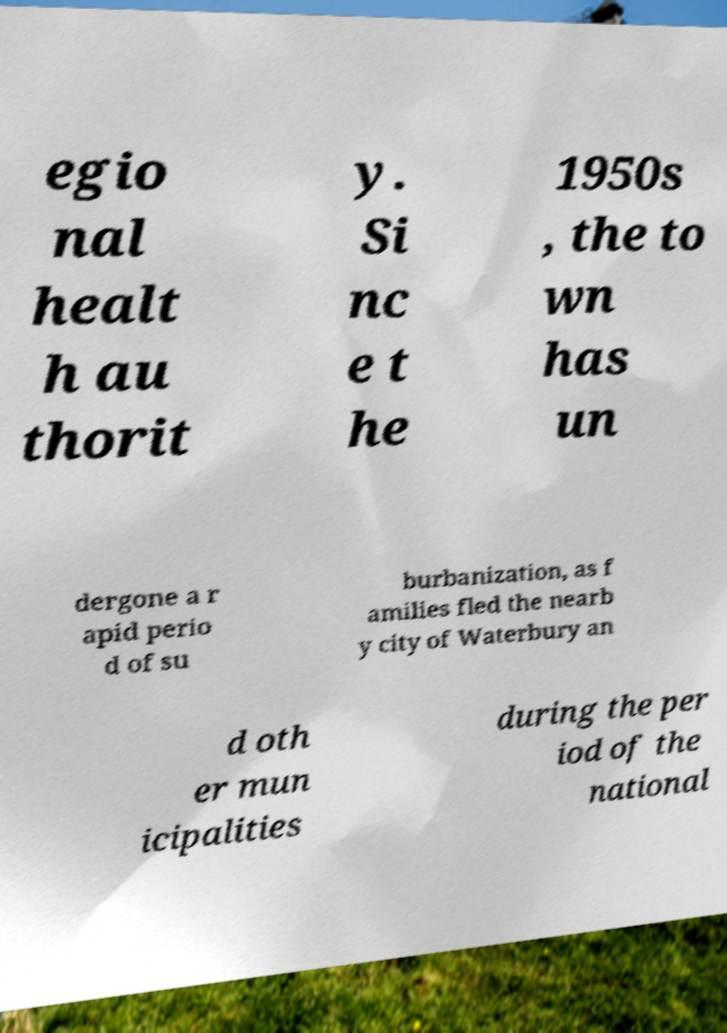I need the written content from this picture converted into text. Can you do that? egio nal healt h au thorit y. Si nc e t he 1950s , the to wn has un dergone a r apid perio d of su burbanization, as f amilies fled the nearb y city of Waterbury an d oth er mun icipalities during the per iod of the national 